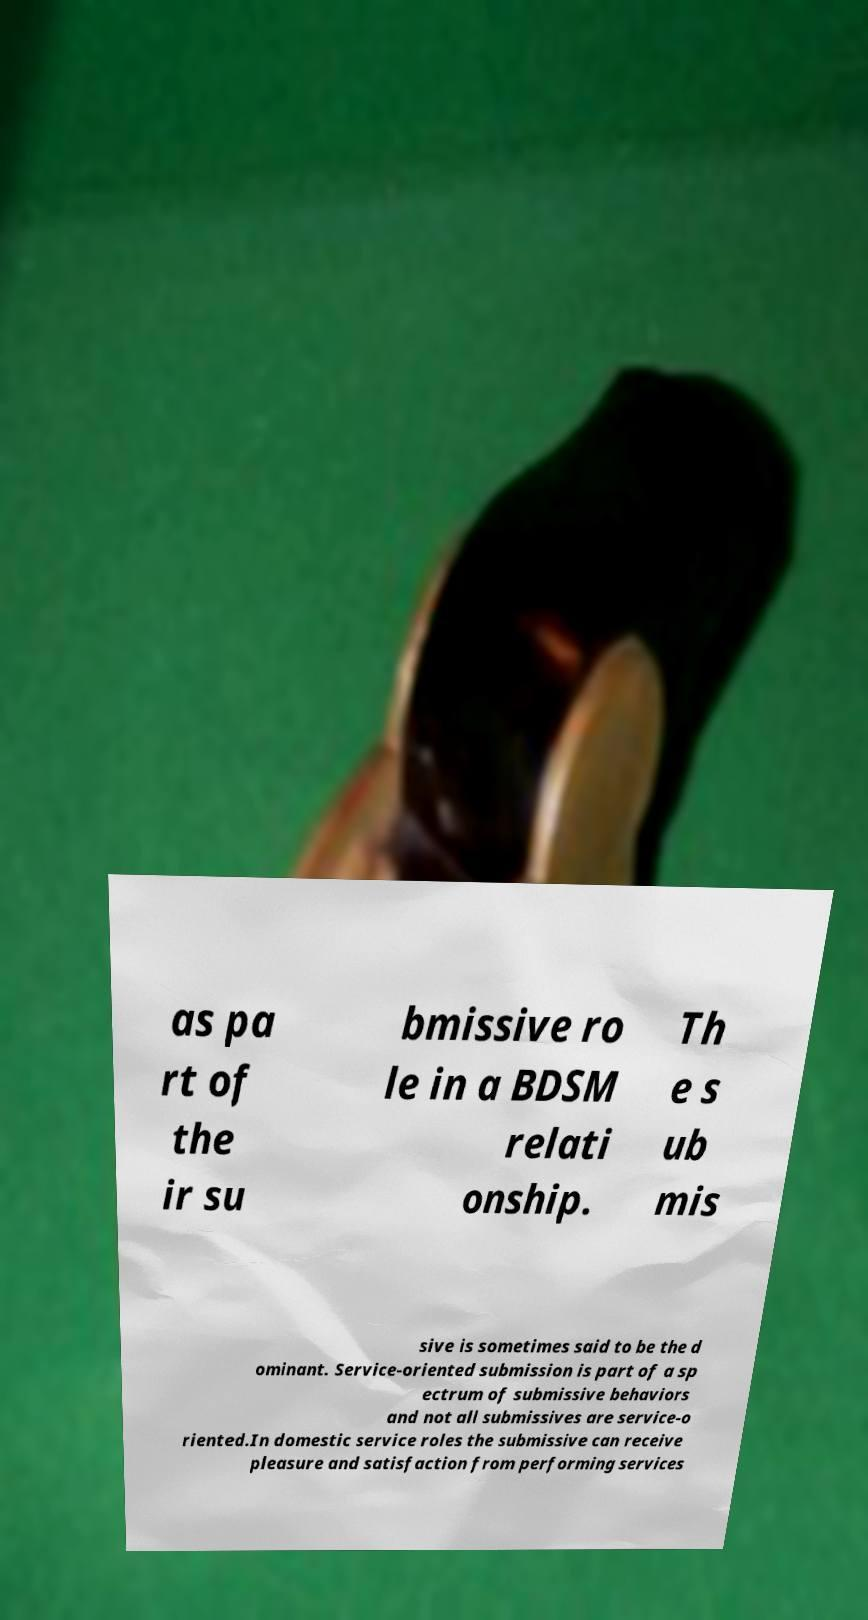For documentation purposes, I need the text within this image transcribed. Could you provide that? as pa rt of the ir su bmissive ro le in a BDSM relati onship. Th e s ub mis sive is sometimes said to be the d ominant. Service-oriented submission is part of a sp ectrum of submissive behaviors and not all submissives are service-o riented.In domestic service roles the submissive can receive pleasure and satisfaction from performing services 